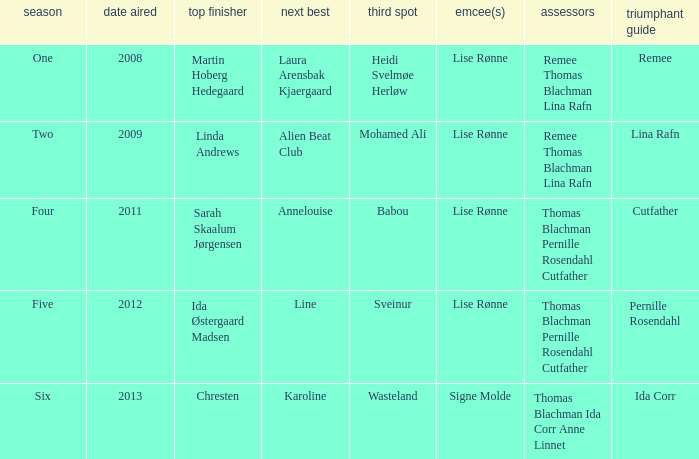Who came in third during the fourth season? Babou. 